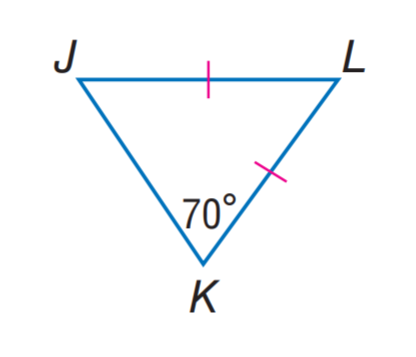Answer the mathemtical geometry problem and directly provide the correct option letter.
Question: Find m \angle J L K.
Choices: A: 30 B: 40 C: 50 D: 70 B 